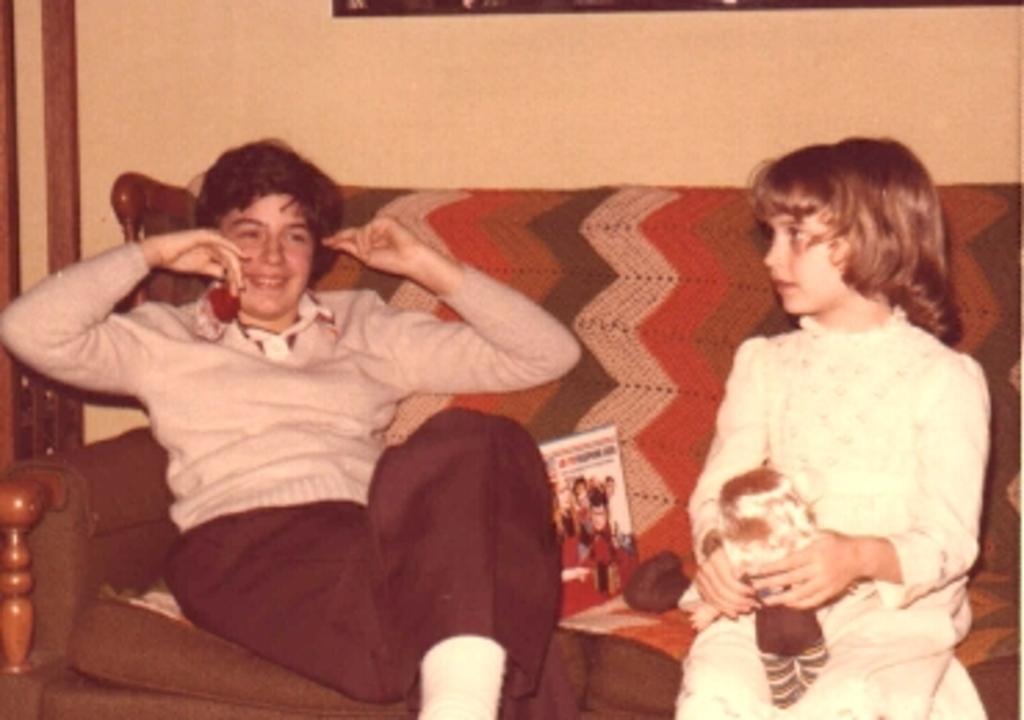Could you give a brief overview of what you see in this image? In this image we can see two people sitting on the sofa, among them one person is holding a phone and another person is holding an object, there are some other objects on the sofa, in the background we can see a wall. 